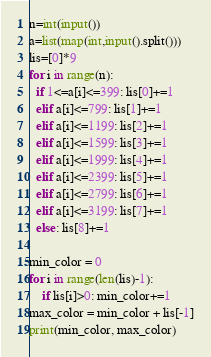Convert code to text. <code><loc_0><loc_0><loc_500><loc_500><_Python_>n=int(input())
a=list(map(int,input().split()))
lis=[0]*9
for i in range(n):
  if 1<=a[i]<=399: lis[0]+=1
  elif a[i]<=799: lis[1]+=1
  elif a[i]<=1199: lis[2]+=1
  elif a[i]<=1599: lis[3]+=1
  elif a[i]<=1999: lis[4]+=1
  elif a[i]<=2399: lis[5]+=1
  elif a[i]<=2799: lis[6]+=1
  elif a[i]<=3199: lis[7]+=1
  else: lis[8]+=1

min_color = 0
for i in range(len(lis)-1):
    if lis[i]>0: min_color+=1
max_color = min_color + lis[-1]
print(min_color, max_color)  </code> 